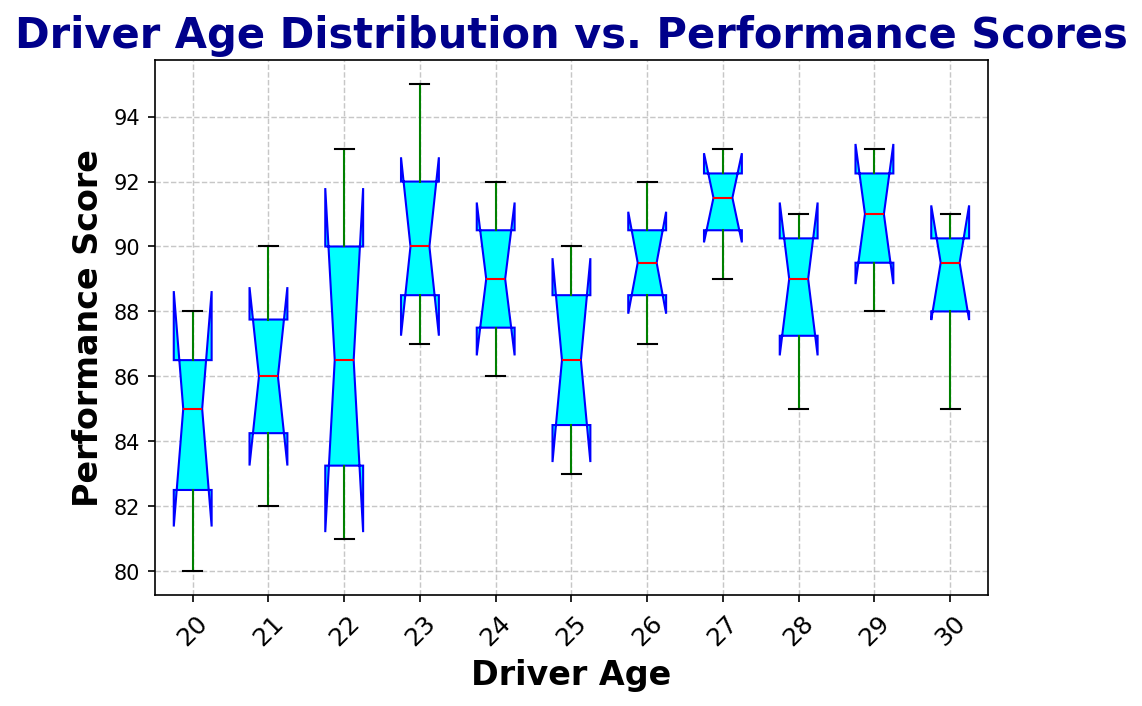Which driver age group has the highest median performance score? By observing the colored lines that indicate the median in each box plot, the highest red line represents the highest median performance score. This is located in the box plot for drivers aged 23.
Answer: Drivers aged 23 What is the interquartile range (IQR) of performance scores for drivers aged 27? The IQR can be found by subtracting the 25th percentile from the 75th percentile. These values are represented by the bottom and top edges of the cyan boxes, respectively, for drivers aged 27.
Answer: 2 (90 to 92) Which age group shows the widest range of performance scores? The range is the difference between the minimum and maximum scores, indicated by the whiskers' ends. The widest range can be found by visually identifying which age group's whiskers cover the largest span. Drivers aged 27 show a wide range of scores from approx. 89 to 93.
Answer: Drivers aged 20 Do any age groups show outliers in performance scores? Typically, outliers are represented by points that fall outside the whiskers of the box plot. In the figure, none of the age groups seem to have individual dots representing outliers.
Answer: No For drivers aged 23 and 24, which group has a higher minimum performance score? The minimum performance score is indicated by the lower end of the whiskers. By comparing the minimums, drivers aged 24 have a higher minimum compared to drivers aged 23.
Answer: Drivers aged 24 Are the performance scores more variable for younger drivers (ages 20-22) or older drivers (ages 28-30)? Variability can be assessed by looking at the range and the IQR of the boxes. Younger drivers (20-22) have larger boxes and whiskers compared to older drivers (28-30).
Answer: Younger drivers Which driver age group's performance scores have the smallest interquartile range (IQR)? The interquartile range (IQR) is represented by the height of the boxes. The group with the smallest box has the smallest IQR. Drivers aged 24 show a small IQR; thus, they likely have the smallest range.
Answer: Drivers aged 26 What is the performance score range for drivers aged 22? The range is the difference between the maximum and minimum values within the whiskers. For drivers aged 22, it ranges from approximately 81 to 93. Subtracting these gives the range.
Answer: 12 Do performance scores improve consistently with age? By visually inspecting the medians represented by the red lines, an overall trend can be determined. The medians do seem to increase from age 20 to around age 23-24 and then approach a similar performance level.
Answer: No consistent trend but some improvement until 24 How do the performance scores of drivers aged 25 compare to those aged 29? Comparing the medians and the range of values, drivers aged 29 have slightly higher performance scores with higher maximum scores compared to drivers aged 25.
Answer: Drivers aged 29 have higher scores overall 